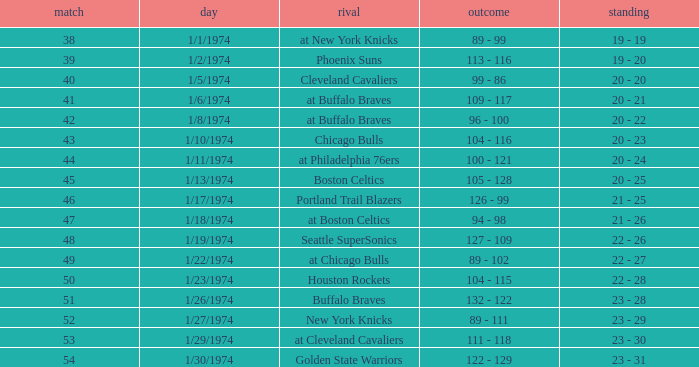What was the score on 1/10/1974? 104 - 116. 